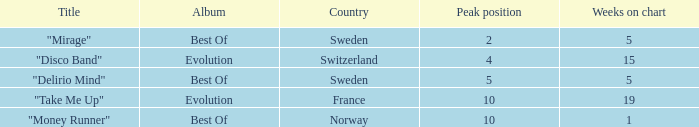What is the title of the track from france that achieved a top 10 ranking? "Take Me Up". 